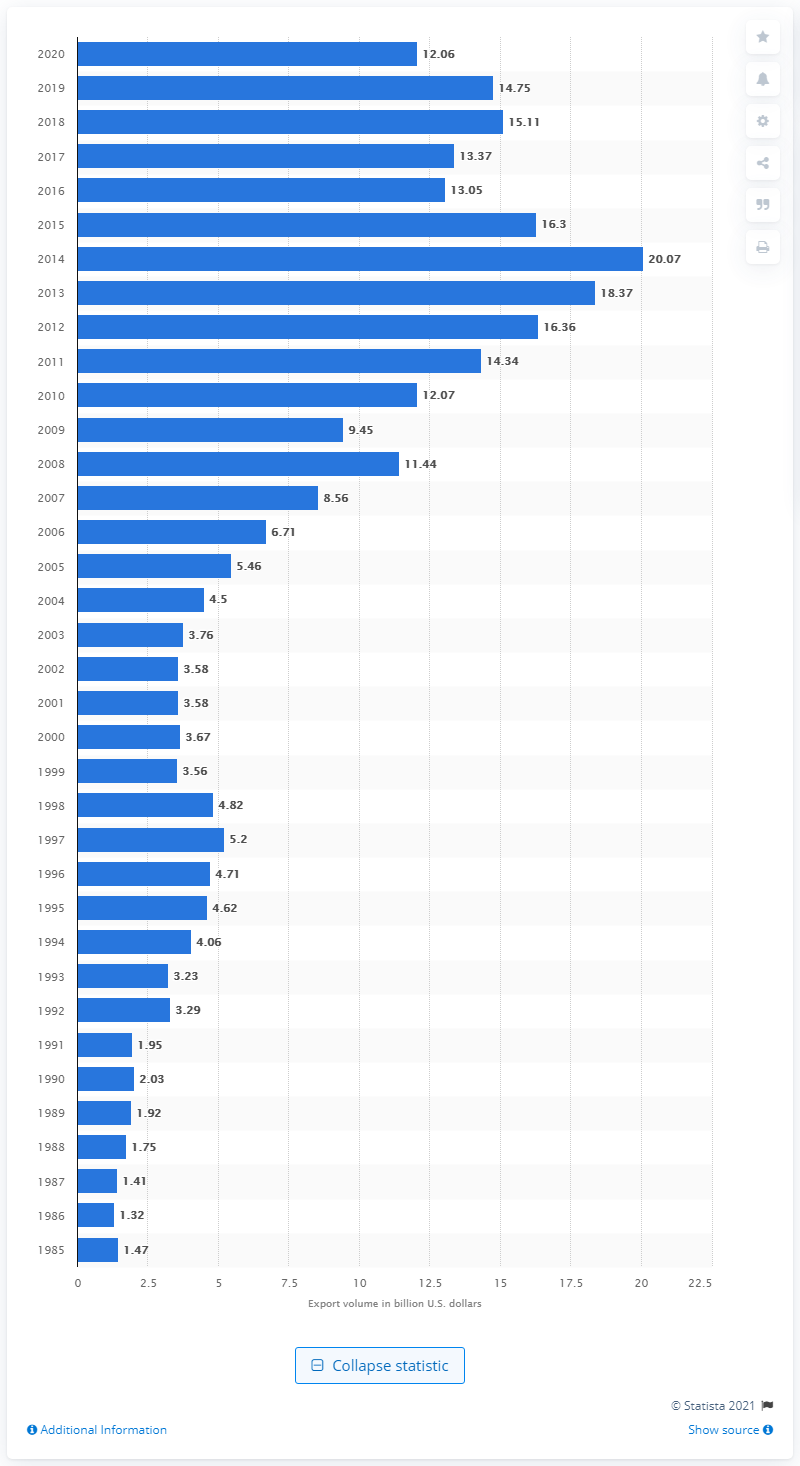How many dollars did the U.S. export to Colombia in 2020? In 2020, the United States exported goods valued at approximately 12.06 billion U.S. dollars to Colombia, reflecting a context of international trade relations between the two countries. 